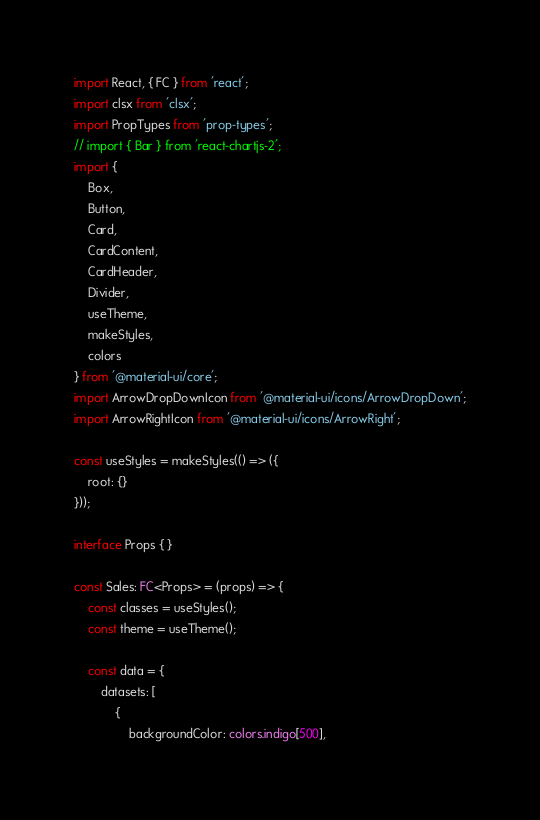<code> <loc_0><loc_0><loc_500><loc_500><_TypeScript_>import React, { FC } from 'react';
import clsx from 'clsx';
import PropTypes from 'prop-types';
// import { Bar } from 'react-chartjs-2';
import {
	Box,
	Button,
	Card,
	CardContent,
	CardHeader,
	Divider,
	useTheme,
	makeStyles,
	colors
} from '@material-ui/core';
import ArrowDropDownIcon from '@material-ui/icons/ArrowDropDown';
import ArrowRightIcon from '@material-ui/icons/ArrowRight';

const useStyles = makeStyles(() => ({
	root: {}
}));

interface Props { }

const Sales: FC<Props> = (props) => {
	const classes = useStyles();
	const theme = useTheme();

	const data = {
		datasets: [
			{
				backgroundColor: colors.indigo[500],</code> 